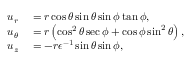Convert formula to latex. <formula><loc_0><loc_0><loc_500><loc_500>\begin{array} { r l } { u _ { r } } & = r \cos \theta \sin \theta \sin \phi \tan \phi , } \\ { u _ { \theta } } & = r \left ( \cos ^ { 2 } \theta \sec \phi + \cos \phi \sin ^ { 2 } \theta \right ) , } \\ { u _ { z } } & = - r \epsilon ^ { - 1 } \sin \theta \sin \phi , } \end{array}</formula> 